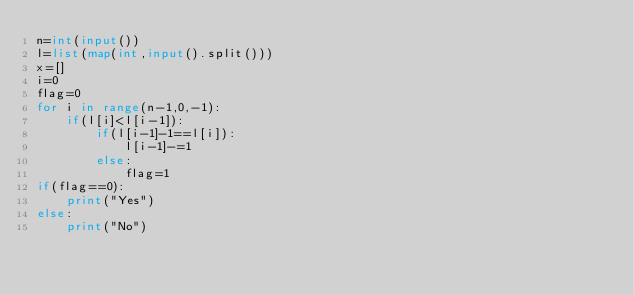<code> <loc_0><loc_0><loc_500><loc_500><_Python_>n=int(input())
l=list(map(int,input().split()))
x=[]
i=0
flag=0
for i in range(n-1,0,-1):
    if(l[i]<l[i-1]):
        if(l[i-1]-1==l[i]):
            l[i-1]-=1
        else:
            flag=1
if(flag==0):
    print("Yes")
else:
    print("No")
        

</code> 